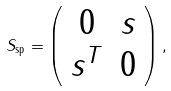Convert formula to latex. <formula><loc_0><loc_0><loc_500><loc_500>S _ { \text {sp} } = \left ( \begin{array} { c c } 0 & s \\ s ^ { T } & 0 \end{array} \right ) ,</formula> 